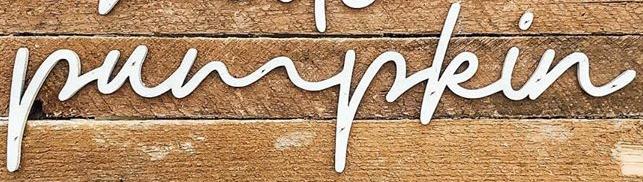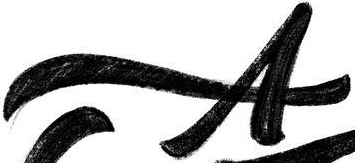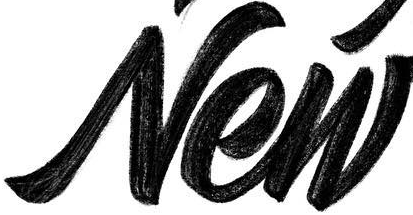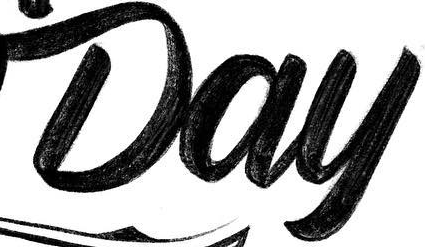What words are shown in these images in order, separated by a semicolon? pumpkin; A; New; Day 